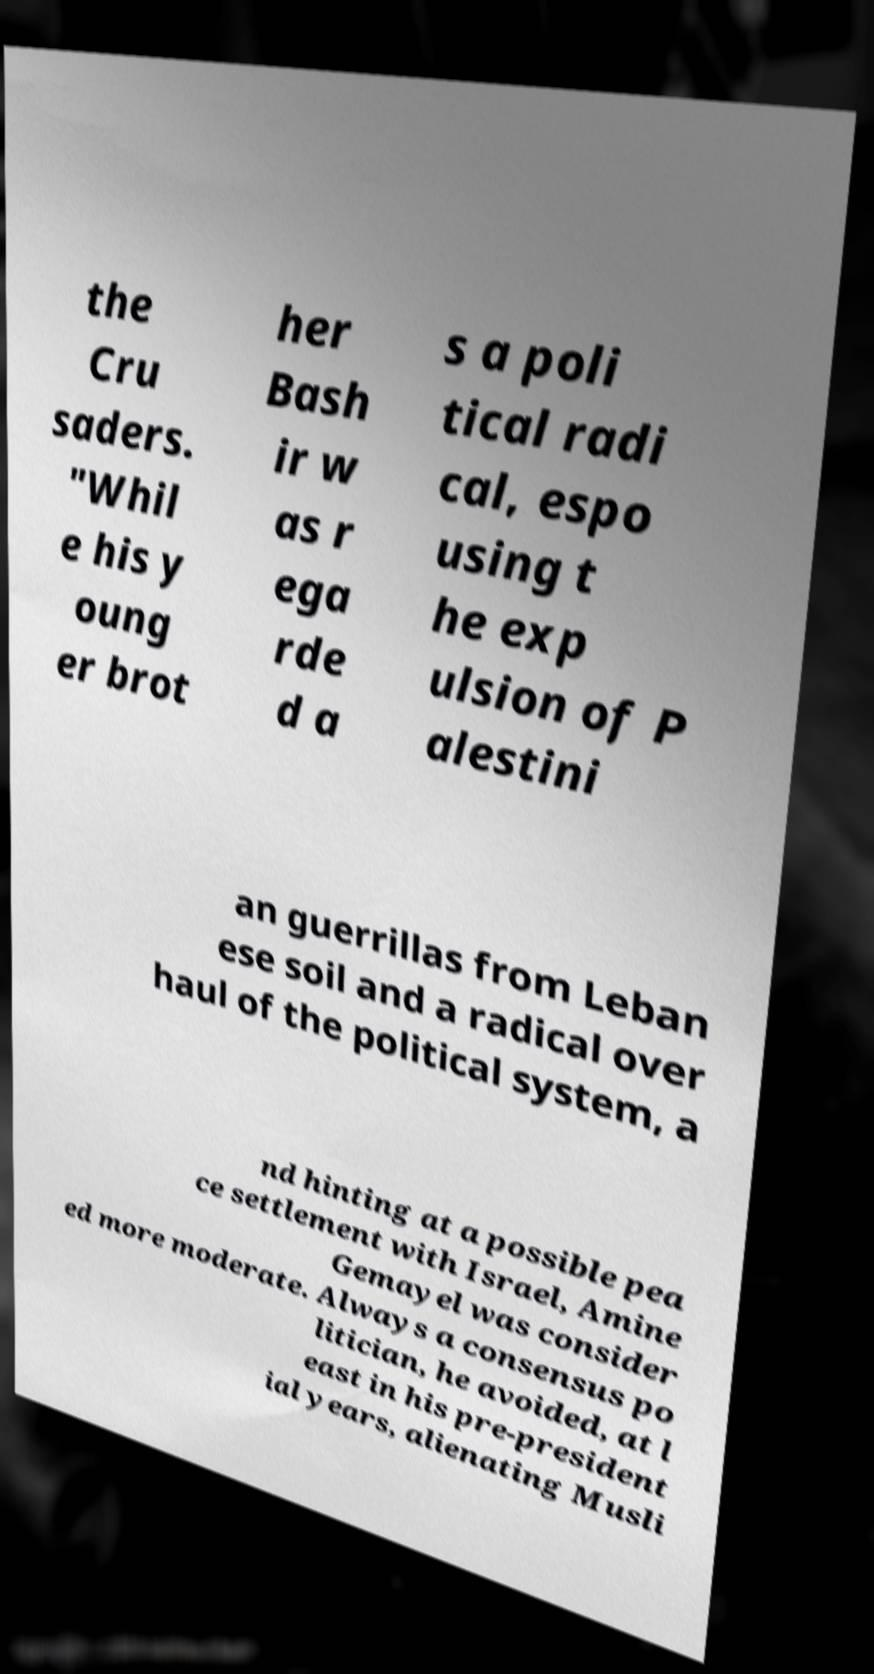What messages or text are displayed in this image? I need them in a readable, typed format. the Cru saders. "Whil e his y oung er brot her Bash ir w as r ega rde d a s a poli tical radi cal, espo using t he exp ulsion of P alestini an guerrillas from Leban ese soil and a radical over haul of the political system, a nd hinting at a possible pea ce settlement with Israel, Amine Gemayel was consider ed more moderate. Always a consensus po litician, he avoided, at l east in his pre-president ial years, alienating Musli 